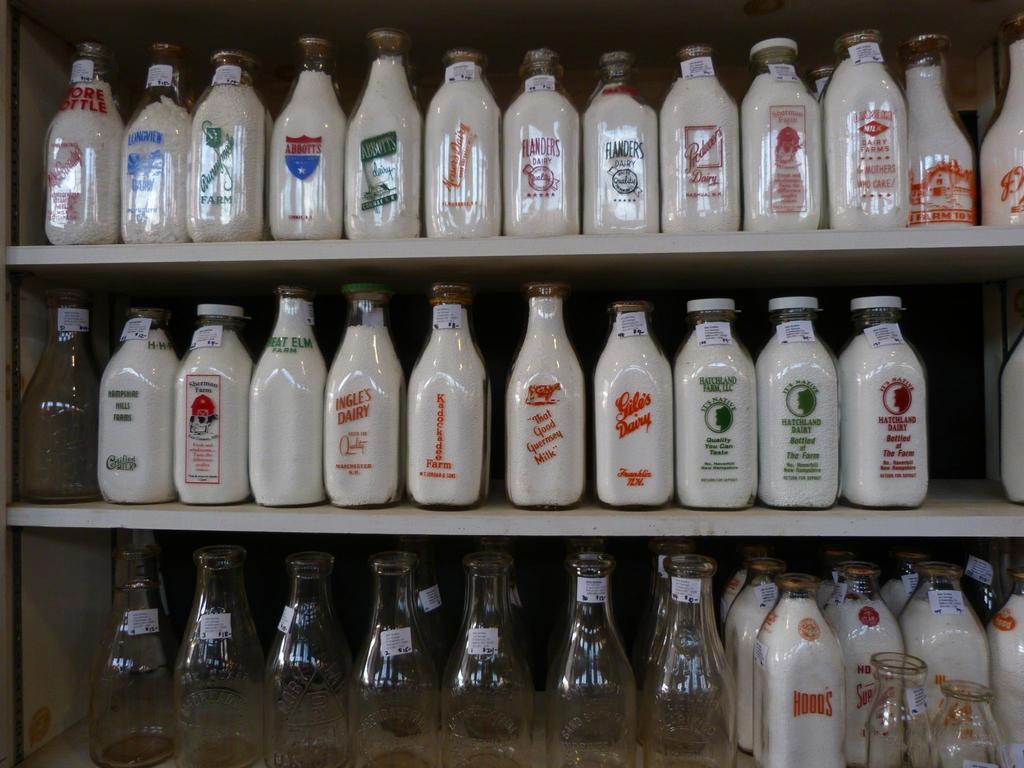What kind of objects are present in the image? There are different types of glass bottles in the image. Can you describe the appearance of the glass bottles? The glass bottles come in various shapes and sizes. What might be the purpose of these glass bottles? The glass bottles could be used for storing liquids or as decorative items. What type of jeans can be seen hanging on the crib in the image? There is no mention of jeans or a crib in the image; it only features different types of glass bottles. 